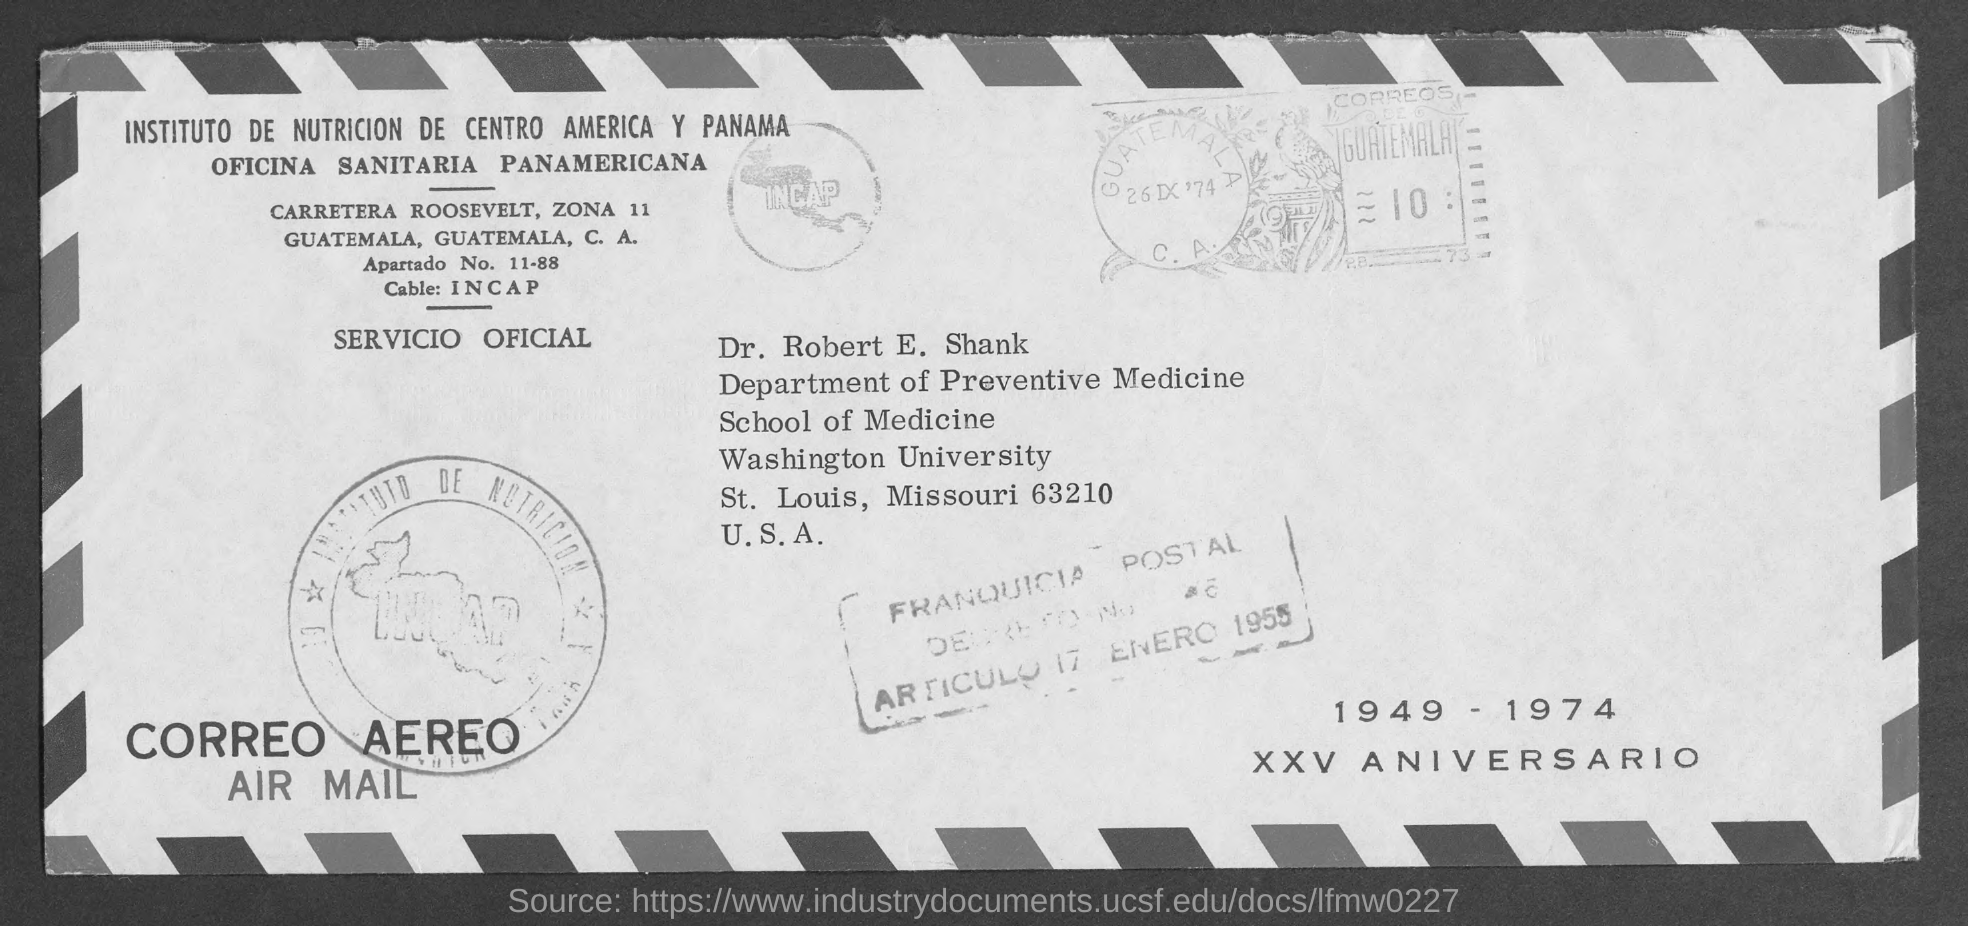Give some essential details in this illustration. The recipient of the mail is "Dr. Robert E. Shank. The sender of this email is located on Carretera Roosevelt. 